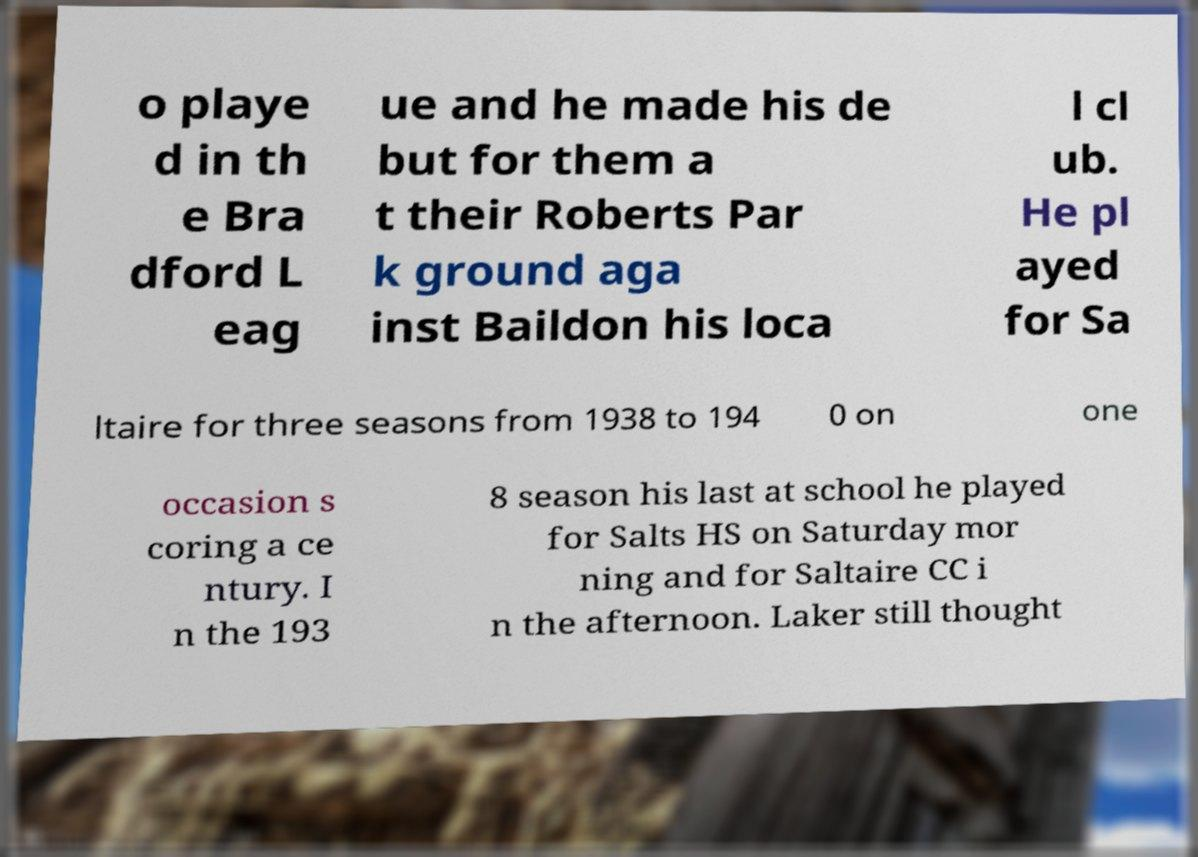Can you accurately transcribe the text from the provided image for me? o playe d in th e Bra dford L eag ue and he made his de but for them a t their Roberts Par k ground aga inst Baildon his loca l cl ub. He pl ayed for Sa ltaire for three seasons from 1938 to 194 0 on one occasion s coring a ce ntury. I n the 193 8 season his last at school he played for Salts HS on Saturday mor ning and for Saltaire CC i n the afternoon. Laker still thought 